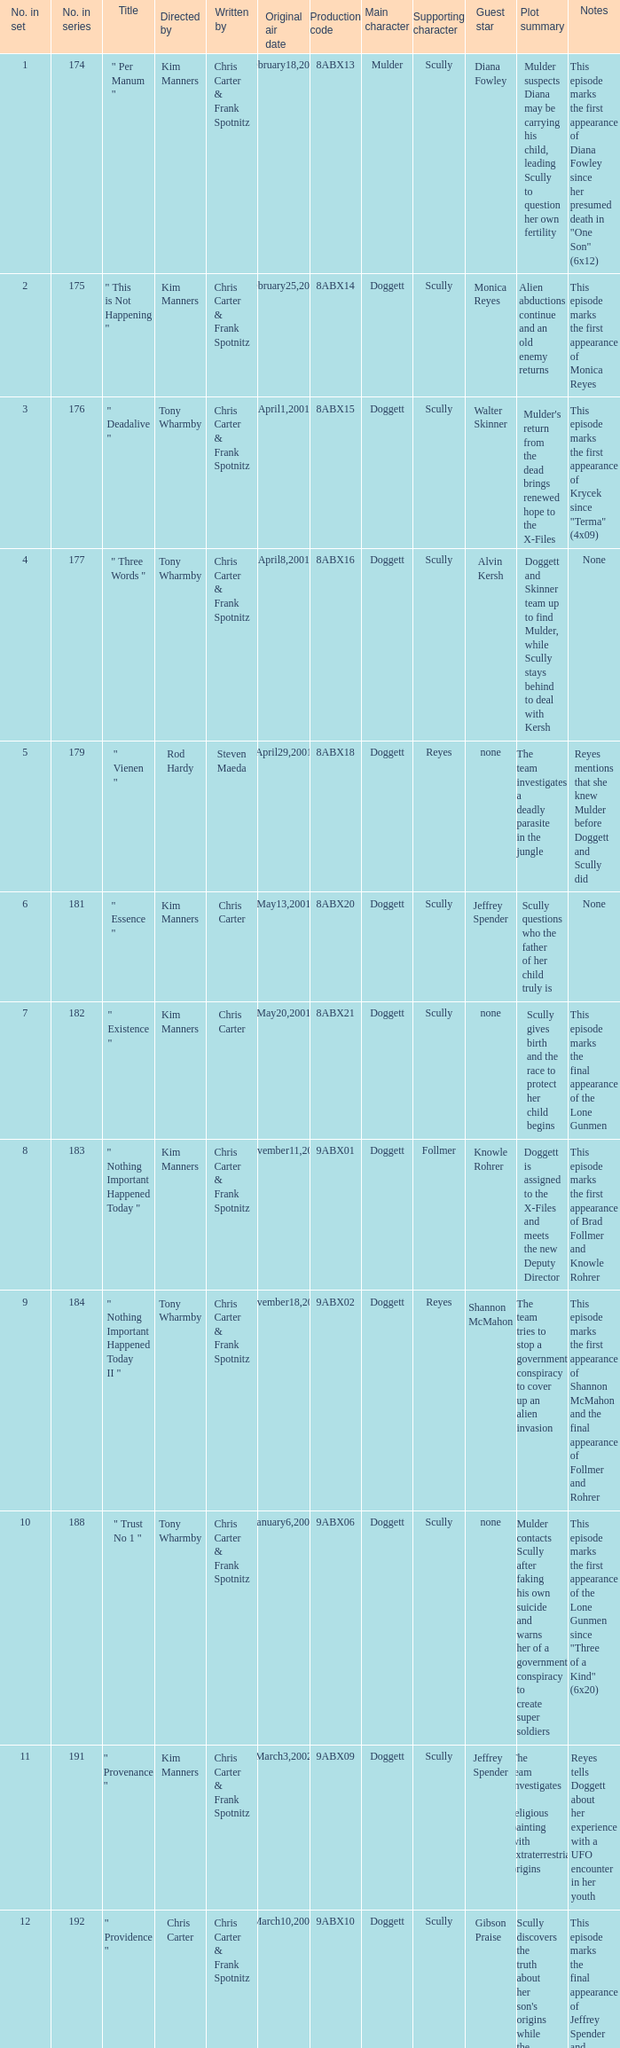What is the episode number that has production code 8abx15? 176.0. 